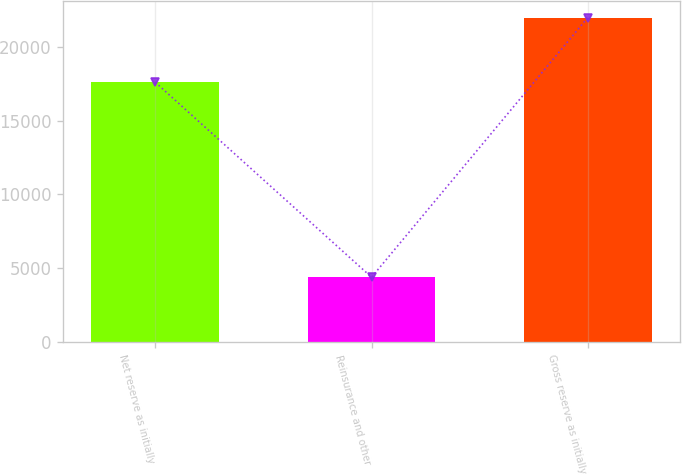<chart> <loc_0><loc_0><loc_500><loc_500><bar_chart><fcel>Net reserve as initially<fcel>Reinsurance and other<fcel>Gross reserve as initially<nl><fcel>17604<fcel>4387<fcel>21991<nl></chart> 